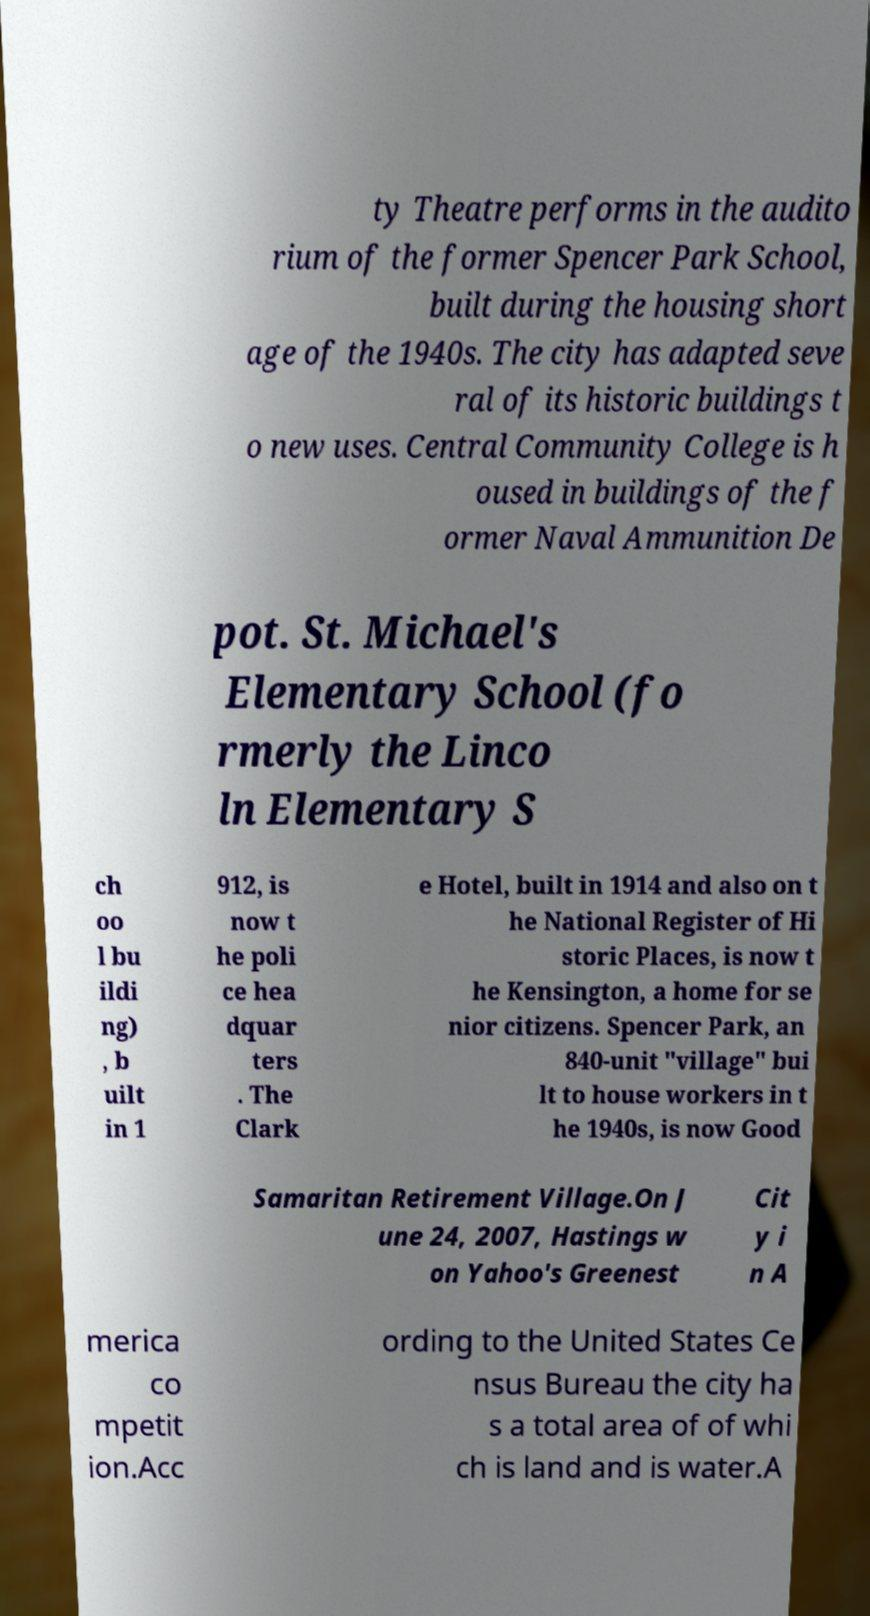Could you extract and type out the text from this image? ty Theatre performs in the audito rium of the former Spencer Park School, built during the housing short age of the 1940s. The city has adapted seve ral of its historic buildings t o new uses. Central Community College is h oused in buildings of the f ormer Naval Ammunition De pot. St. Michael's Elementary School (fo rmerly the Linco ln Elementary S ch oo l bu ildi ng) , b uilt in 1 912, is now t he poli ce hea dquar ters . The Clark e Hotel, built in 1914 and also on t he National Register of Hi storic Places, is now t he Kensington, a home for se nior citizens. Spencer Park, an 840-unit "village" bui lt to house workers in t he 1940s, is now Good Samaritan Retirement Village.On J une 24, 2007, Hastings w on Yahoo's Greenest Cit y i n A merica co mpetit ion.Acc ording to the United States Ce nsus Bureau the city ha s a total area of of whi ch is land and is water.A 